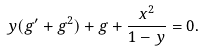Convert formula to latex. <formula><loc_0><loc_0><loc_500><loc_500>y ( g ^ { \prime } + g ^ { 2 } ) + g + \frac { x ^ { 2 } } { 1 - y } = 0 .</formula> 